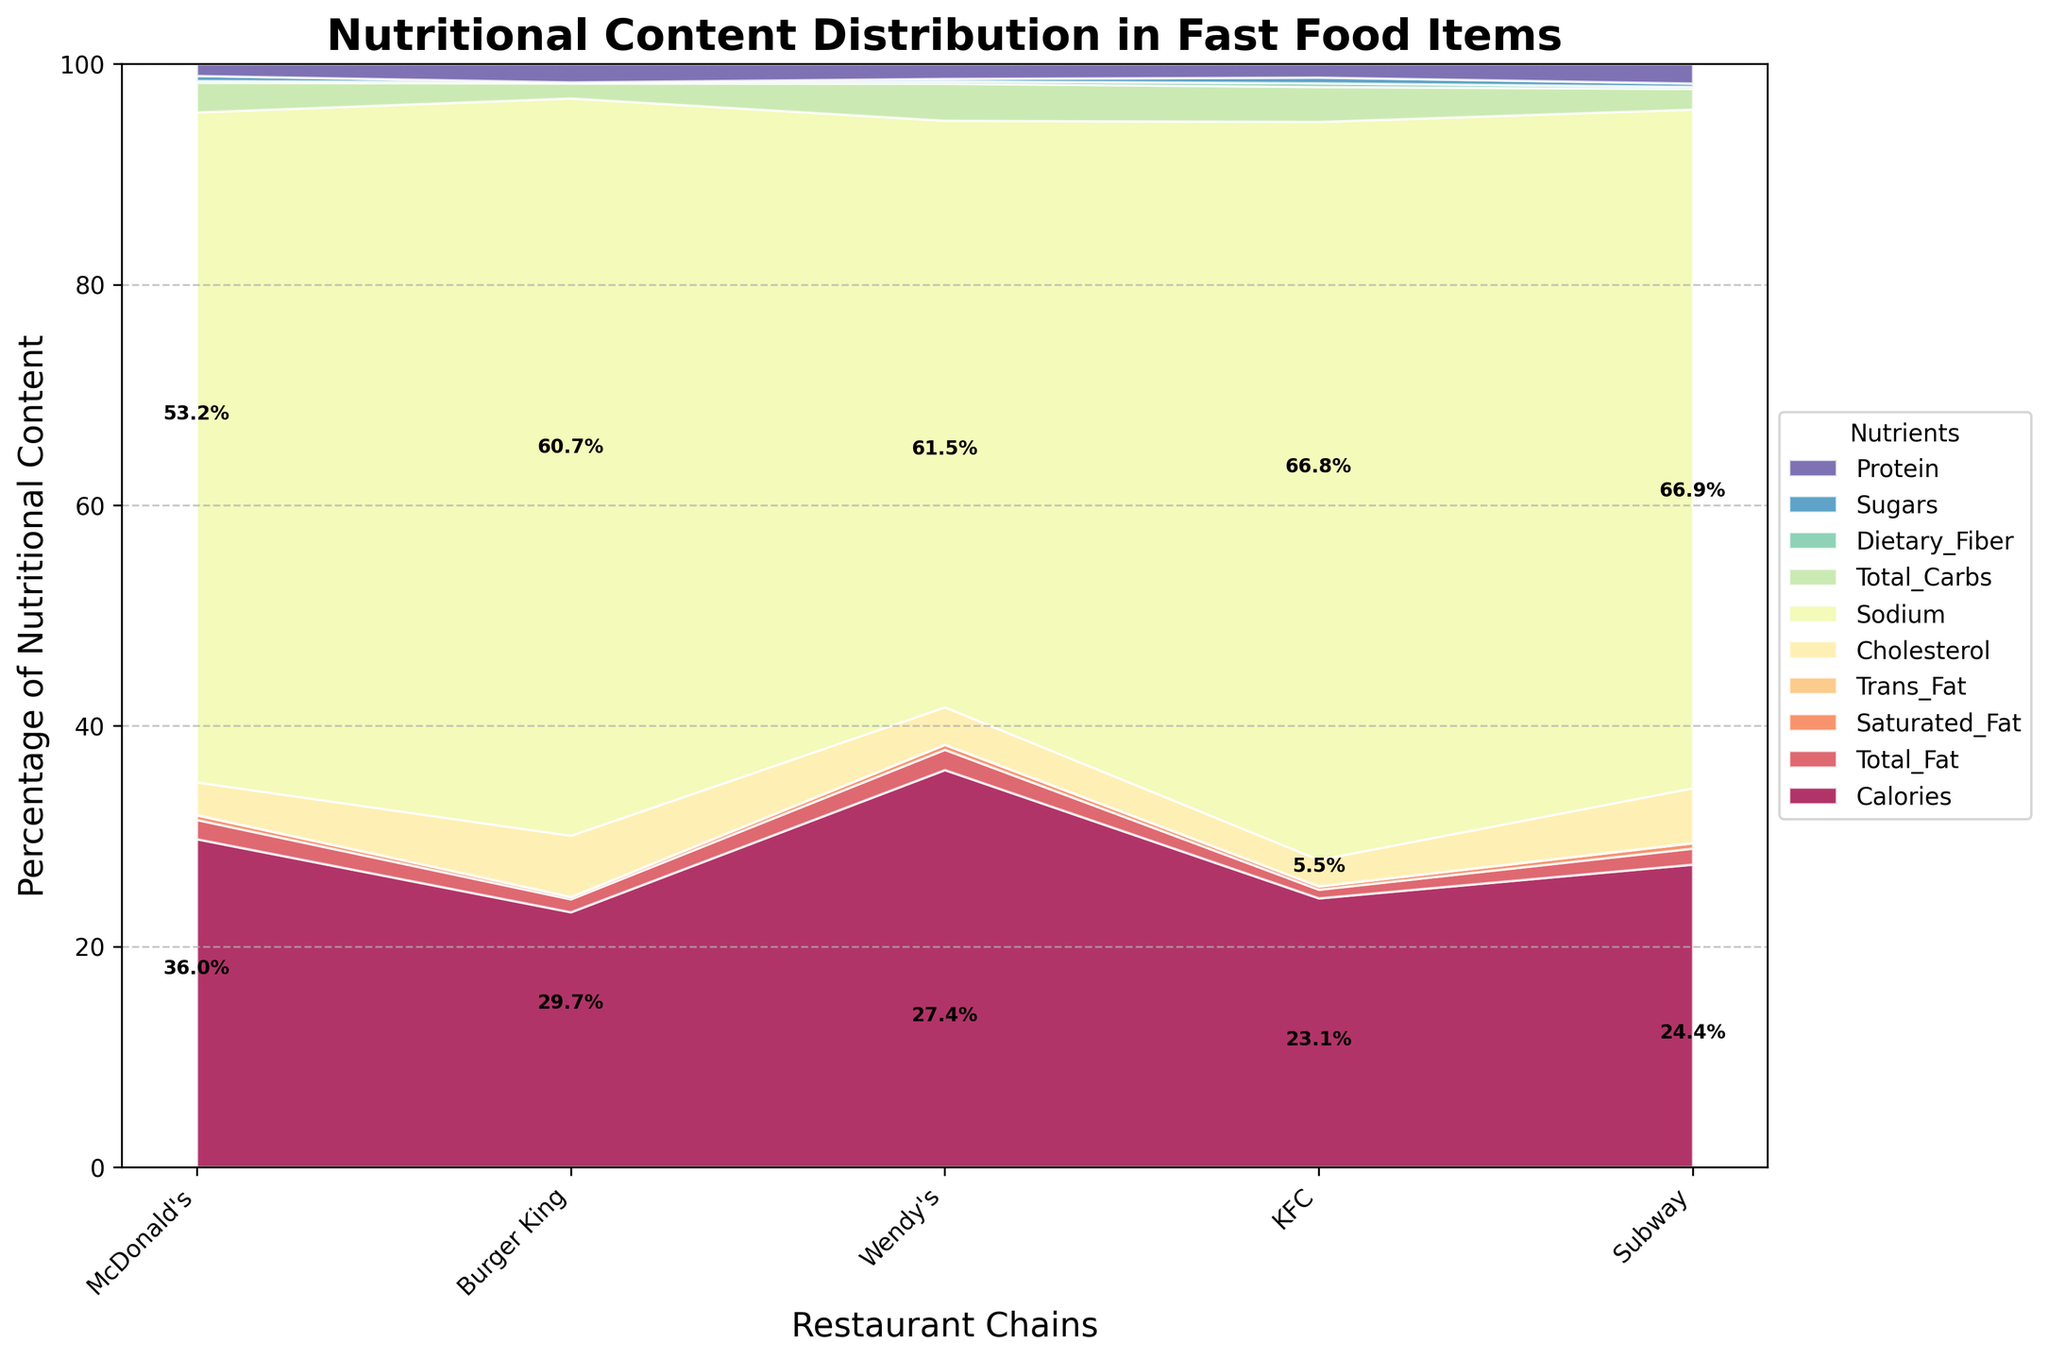What's the title of the chart? The title is prominently displayed at the top of the chart, above the actual data visualization area.
Answer: Nutritional Content Distribution in Fast Food Items What are the restaurant chains included in the chart? The restaurant chains are labeled on the x-axis, with each chain's name clearly displayed.
Answer: McDonald's, Burger King, Wendy's, KFC, Subway Which nutrient has the largest percentage in any restaurant chain? Look at the highest segments in each stack. Wendy's "Baconator" has the largest segment for 'Sodium'.
Answer: Sodium How does the percentage of protein content in Subway compare to KFC? Identify the segments for 'Protein' in Subway and KFC and compare their heights within their respective stacks.
Answer: Higher in KFC What nutrient makes up the smallest percentage in Burger King? Examine the stacked segments for Burger King and find the smallest one.
Answer: Trans Fat Can you list the nutrients in descending order of their percentage in a Subway item? Within the Subway stack, inspect each segment's relative height and order them accordingly.
Answer: Carbohydrates, Protein, Sodium, Sugars, Total Fat, Dietary Fiber, Calories, Saturated Fat, Cholesterol, Trans Fat What is the second largest nutrient in McDonald's fast food items? Look at McDonald's stack and find the second highest segment.
Answer: Carbohydrates How does the distribution of total carbs compare between Wendy's and Burger King? Compare the segments corresponding to 'Total Carbs' between Wendy's and Burger King, observing their relative heights.
Answer: Lower in Wendy's What percentage of Wendy's nutritional content is made up of 'Sodium'? Identify the segment corresponding to 'Sodium' in Wendy's and note the percentage value displayed.
Answer: 58.2% Which nutrient in KFC has a notably small percentage that might be highlighted for its health benefits? Find a minor segment within KFC's stack that can be seen as beneficial (for example, low 'Total Fat' or high 'Protein').
Answer: Trans Fat, Total Carbs 